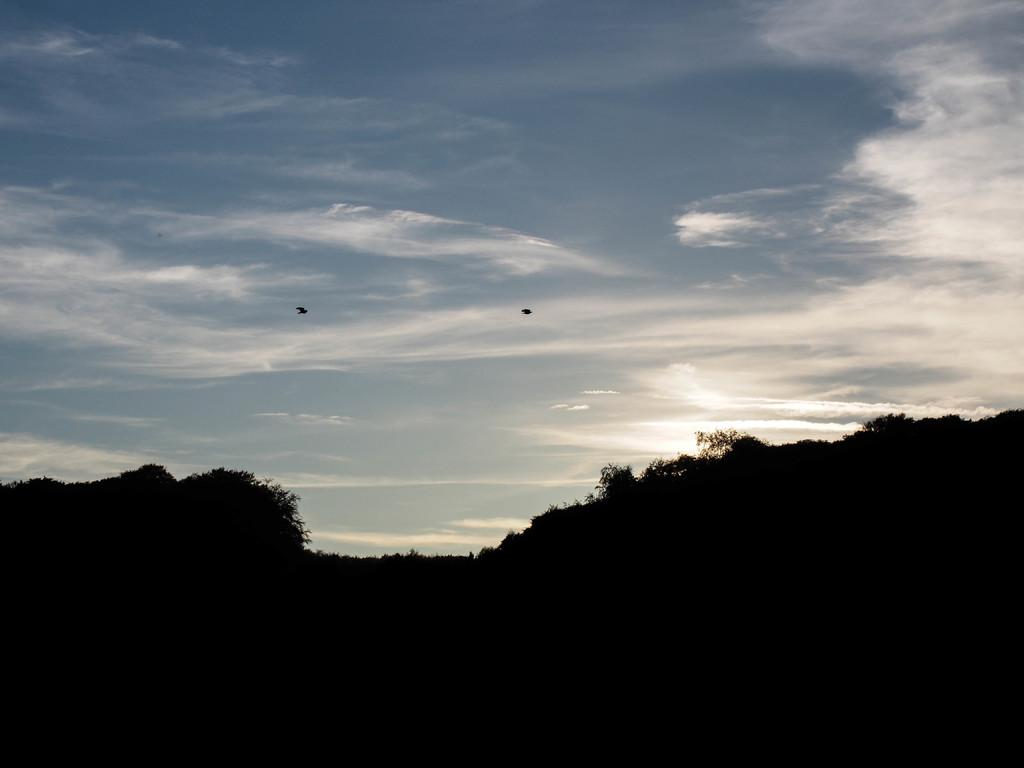What type of landscape is depicted in the image? There are hills in the image. What other natural elements can be seen in the image? There are trees in the image. How would you describe the sky in the image? The sky is cloudy and pale blue. What is happening in the sky in the image? Birds are flying in the sky. Can you tell me what type of lock is being used by the writer in the image? There is no writer or lock present in the image; it features hills, trees, a cloudy sky, and flying birds. 